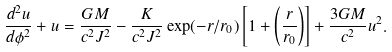Convert formula to latex. <formula><loc_0><loc_0><loc_500><loc_500>\frac { d ^ { 2 } u } { d \phi ^ { 2 } } + u = \frac { G M } { c ^ { 2 } J ^ { 2 } } - \frac { K } { c ^ { 2 } J ^ { 2 } } \exp ( - r / r _ { 0 } ) \left [ 1 + \left ( \frac { r } { r _ { 0 } } \right ) \right ] + \frac { 3 G M } { c ^ { 2 } } u ^ { 2 } .</formula> 